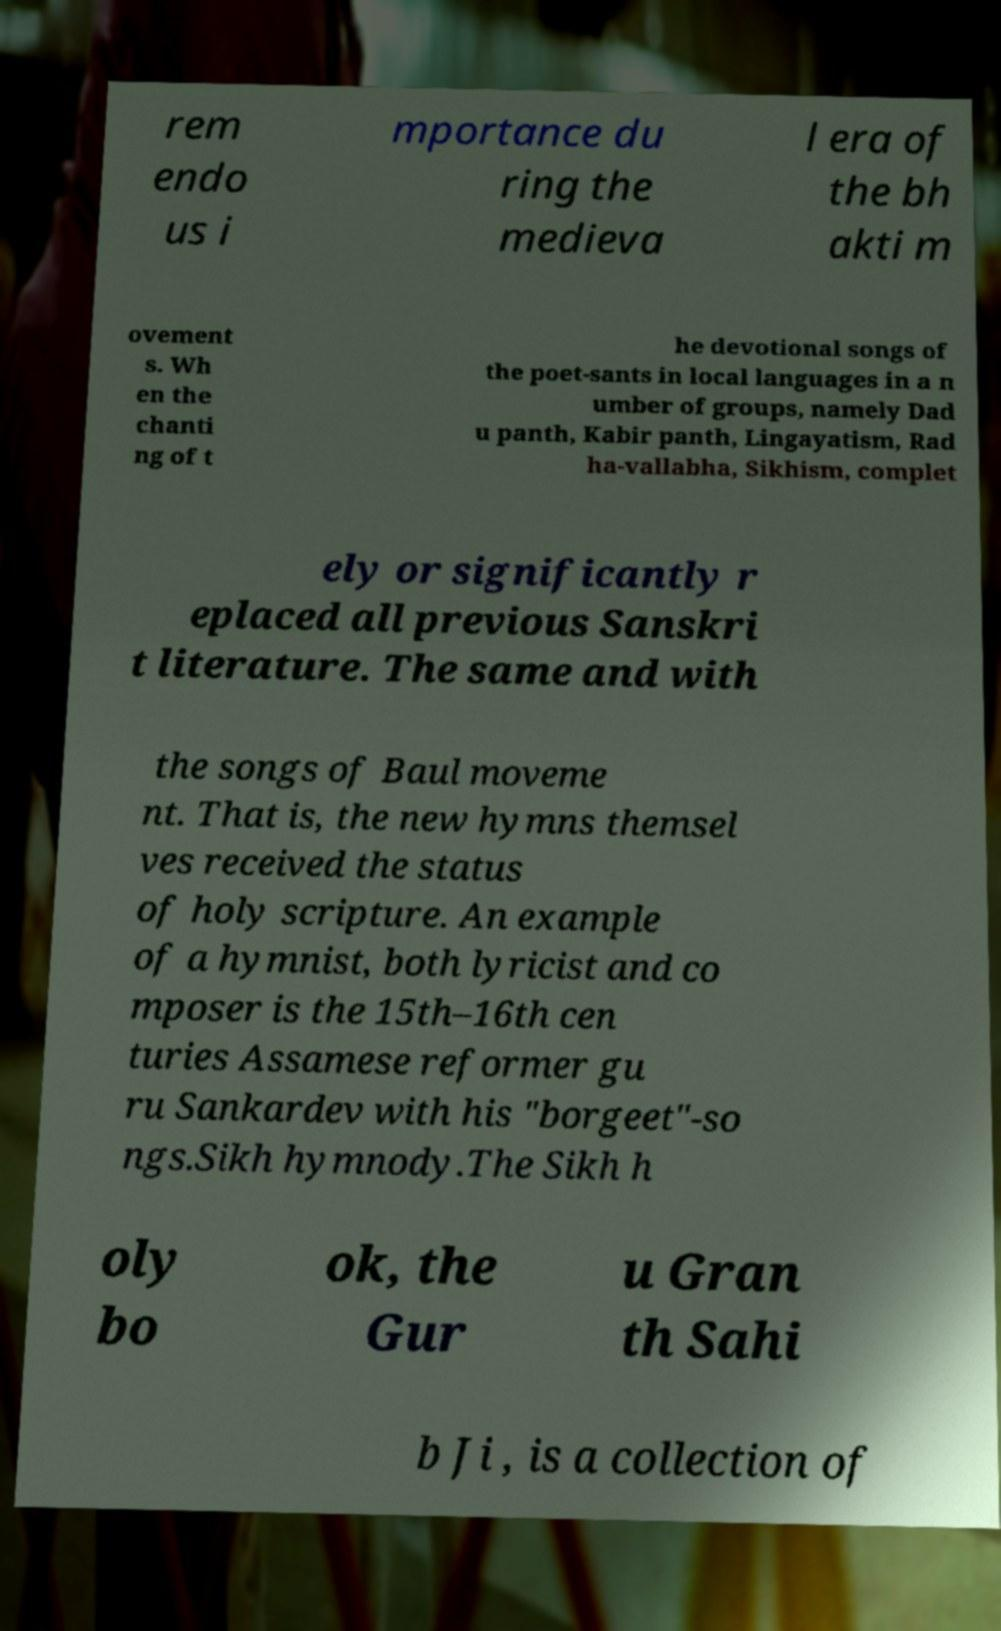Can you read and provide the text displayed in the image?This photo seems to have some interesting text. Can you extract and type it out for me? rem endo us i mportance du ring the medieva l era of the bh akti m ovement s. Wh en the chanti ng of t he devotional songs of the poet-sants in local languages in a n umber of groups, namely Dad u panth, Kabir panth, Lingayatism, Rad ha-vallabha, Sikhism, complet ely or significantly r eplaced all previous Sanskri t literature. The same and with the songs of Baul moveme nt. That is, the new hymns themsel ves received the status of holy scripture. An example of a hymnist, both lyricist and co mposer is the 15th–16th cen turies Assamese reformer gu ru Sankardev with his "borgeet"-so ngs.Sikh hymnody.The Sikh h oly bo ok, the Gur u Gran th Sahi b Ji , is a collection of 